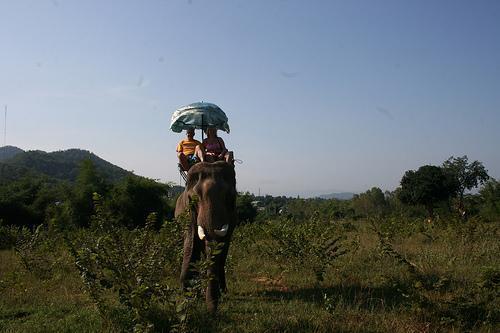How many people are in the photo?
Give a very brief answer. 2. 